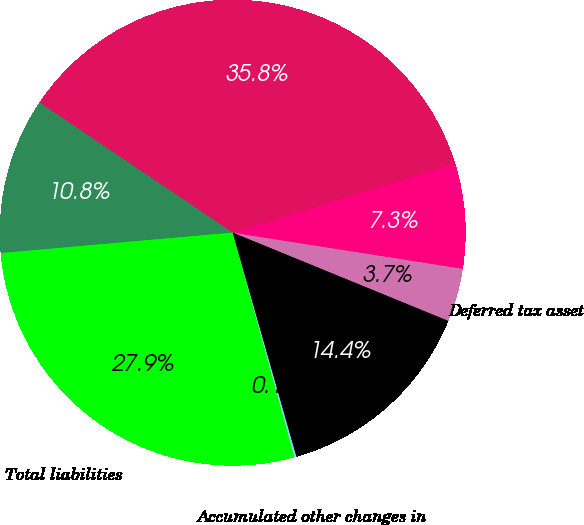Convert chart to OTSL. <chart><loc_0><loc_0><loc_500><loc_500><pie_chart><fcel>Deferred tax asset<fcel>Other assets<fcel>Total assets<fcel>Other liabilities<fcel>Total liabilities<fcel>Accumulated other changes in<fcel>Total shareholders' equity<nl><fcel>3.71%<fcel>7.27%<fcel>35.78%<fcel>10.83%<fcel>27.87%<fcel>0.14%<fcel>14.4%<nl></chart> 